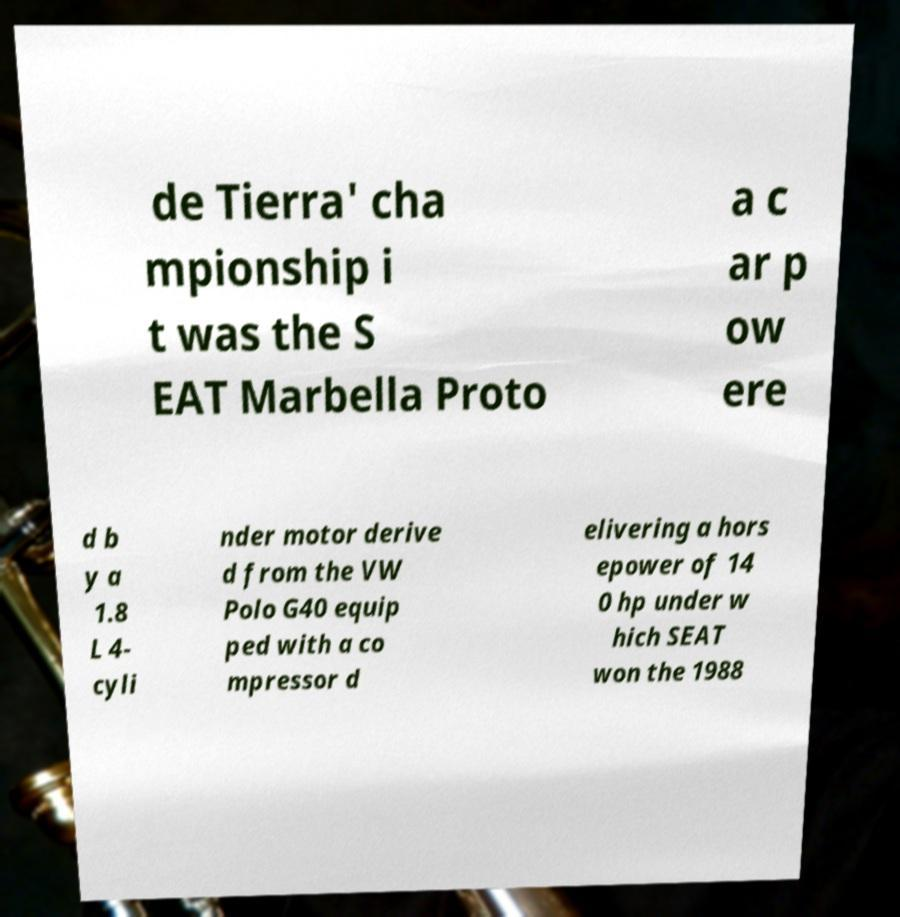Please identify and transcribe the text found in this image. de Tierra' cha mpionship i t was the S EAT Marbella Proto a c ar p ow ere d b y a 1.8 L 4- cyli nder motor derive d from the VW Polo G40 equip ped with a co mpressor d elivering a hors epower of 14 0 hp under w hich SEAT won the 1988 